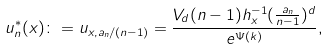Convert formula to latex. <formula><loc_0><loc_0><loc_500><loc_500>u _ { n } ^ { * } ( x ) \colon = u _ { x , a _ { n } / ( n - 1 ) } = \frac { V _ { d } ( n - 1 ) h _ { x } ^ { - 1 } ( \frac { a _ { n } } { n - 1 } ) ^ { d } } { e ^ { \Psi ( k ) } } ,</formula> 